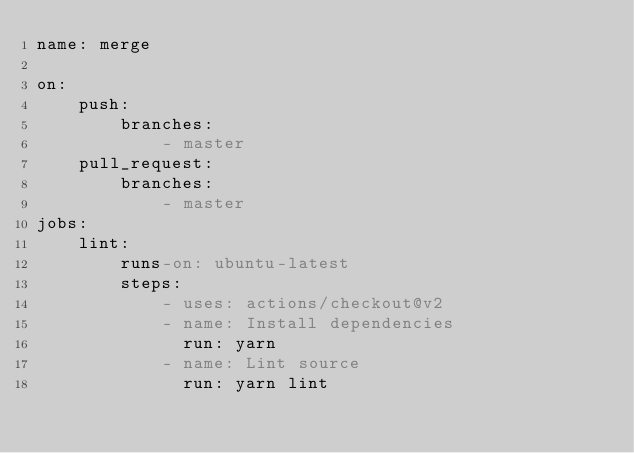<code> <loc_0><loc_0><loc_500><loc_500><_YAML_>name: merge

on:
    push:
        branches:
            - master
    pull_request:
        branches:
            - master
jobs:
    lint:
        runs-on: ubuntu-latest
        steps:
            - uses: actions/checkout@v2
            - name: Install dependencies
              run: yarn
            - name: Lint source
              run: yarn lint
</code> 